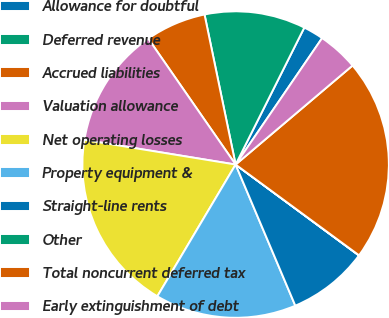Convert chart. <chart><loc_0><loc_0><loc_500><loc_500><pie_chart><fcel>Allowance for doubtful<fcel>Deferred revenue<fcel>Accrued liabilities<fcel>Valuation allowance<fcel>Net operating losses<fcel>Property equipment &<fcel>Straight-line rents<fcel>Other<fcel>Total noncurrent deferred tax<fcel>Early extinguishment of debt<nl><fcel>2.15%<fcel>10.65%<fcel>6.4%<fcel>12.77%<fcel>19.04%<fcel>14.9%<fcel>8.52%<fcel>0.02%<fcel>21.27%<fcel>4.27%<nl></chart> 